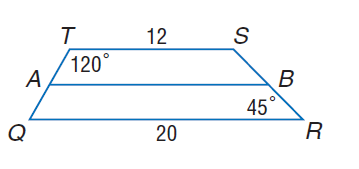Answer the mathemtical geometry problem and directly provide the correct option letter.
Question: For trapezoid Q R S T, A and B are midpoints of the legs. Find m \angle Q.
Choices: A: 45 B: 60 C: 120 D: 135 B 